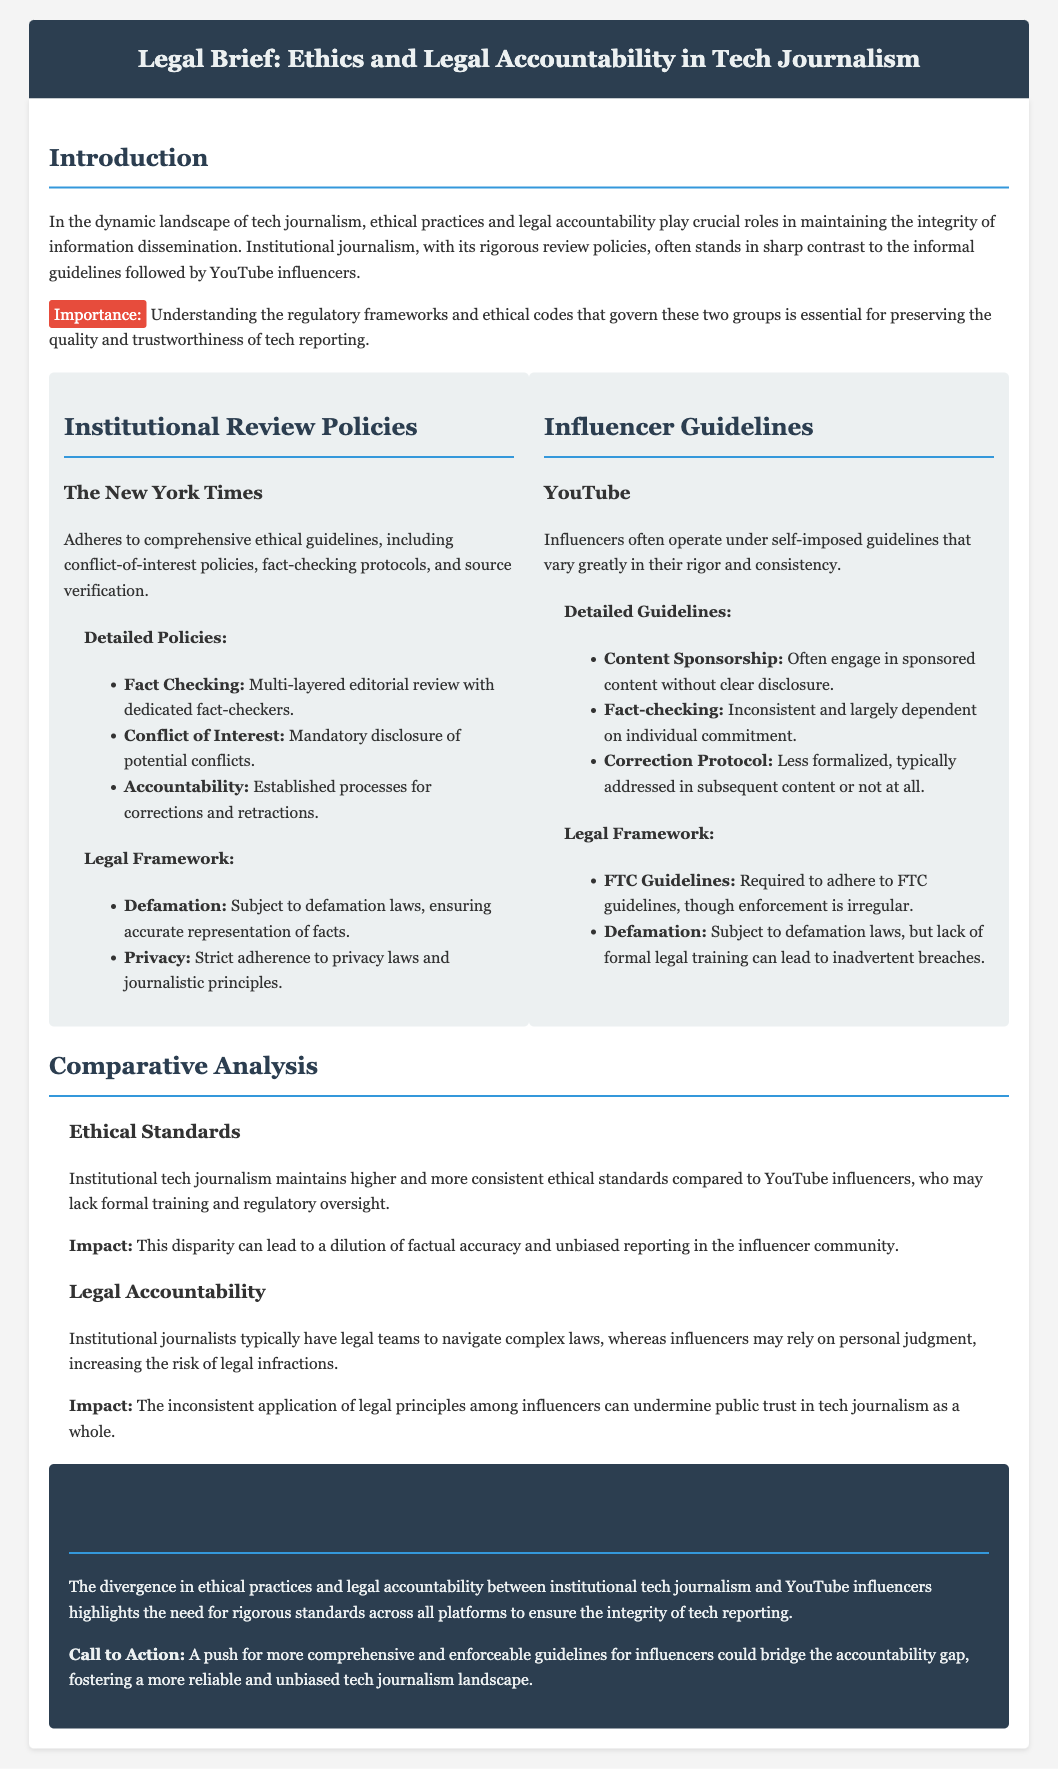what organization's ethical guidelines emphasize conflict-of-interest policies? The document mentions The New York Times as adhering to comprehensive ethical guidelines, including conflict-of-interest policies.
Answer: The New York Times what legal issue do institutional journalists adhere to regarding personal information? The legal section states that institutional journalists follow strict adherence to privacy laws and journalistic principles.
Answer: Privacy how do YouTube influencers typically handle content sponsorship disclosure? The guidelines indicate that YouTube influencers often engage in sponsored content without clear disclosure.
Answer: Without clear disclosure what is one of the legal frameworks that influencers are required to adhere to? The document states that influencers must comply with FTC guidelines, although enforcement may be irregular.
Answer: FTC guidelines how do the ethical standards of institutional journalism compare to those of YouTube influencers? The comparative analysis highlights that institutional tech journalism maintains higher and more consistent ethical standards.
Answer: Higher and more consistent what is the impact of inconsistent application of legal principles among influencers? The document states that this inconsistency can undermine public trust in tech journalism as a whole.
Answer: Undermining public trust what conclusion does the document reach regarding technical journalism integrity? The conclusion emphasizes the need for rigorous standards across all platforms to ensure the integrity of tech reporting.
Answer: Need for rigorous standards how many layers are involved in the fact-checking process at The New York Times? The section on The New York Times emphasizes a multi-layered editorial review process.
Answer: Multi-layered how are corrections and retractions handled in institutional journalism? Accountability in institutional journalism includes established processes for corrections and retractions.
Answer: Established processes what type of impact does a disparity in ethical standards cause? According to the document, this disparity can lead to a dilution of factual accuracy and unbiased reporting.
Answer: Dilution of factual accuracy 